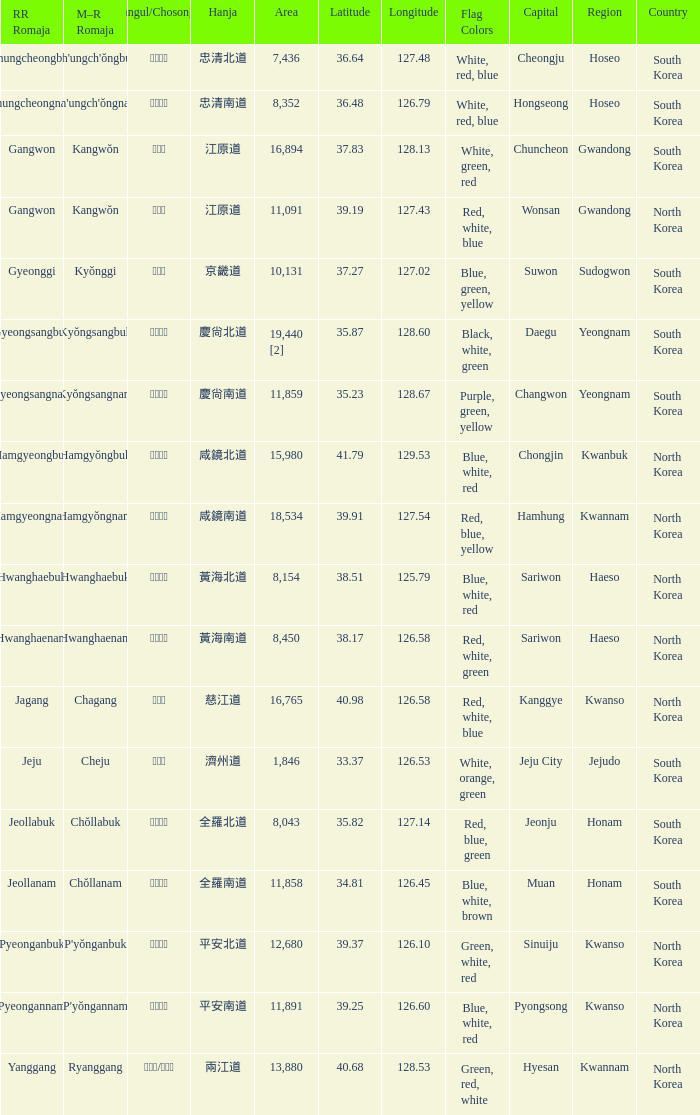What is the area for the province having Hangul of 경기도? 10131.0. 